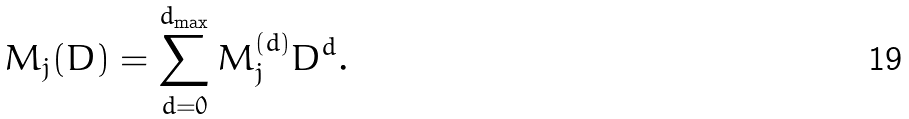<formula> <loc_0><loc_0><loc_500><loc_500>M _ { j } ( D ) = \sum _ { d = 0 } ^ { d _ { \max } } M _ { j } ^ { ( d ) } D ^ { d } .</formula> 